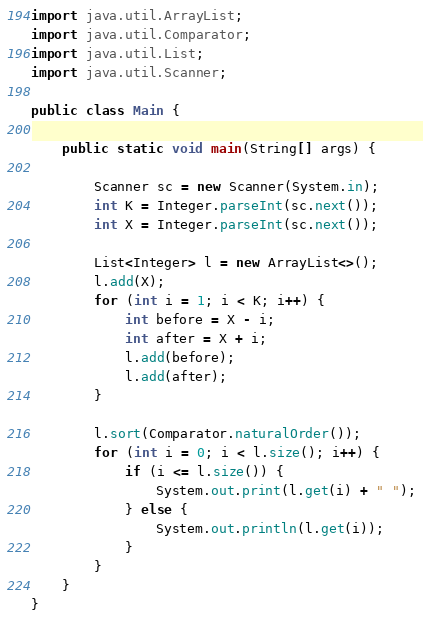Convert code to text. <code><loc_0><loc_0><loc_500><loc_500><_Java_>import java.util.ArrayList;
import java.util.Comparator;
import java.util.List;
import java.util.Scanner;

public class Main {

    public static void main(String[] args) {

        Scanner sc = new Scanner(System.in);
        int K = Integer.parseInt(sc.next());
        int X = Integer.parseInt(sc.next());

        List<Integer> l = new ArrayList<>();
        l.add(X);
        for (int i = 1; i < K; i++) {
            int before = X - i;
            int after = X + i;
            l.add(before);
            l.add(after);
        }

        l.sort(Comparator.naturalOrder());
        for (int i = 0; i < l.size(); i++) {
            if (i <= l.size()) {
                System.out.print(l.get(i) + " ");
            } else {
                System.out.println(l.get(i));
            }
        }
    }
}
</code> 